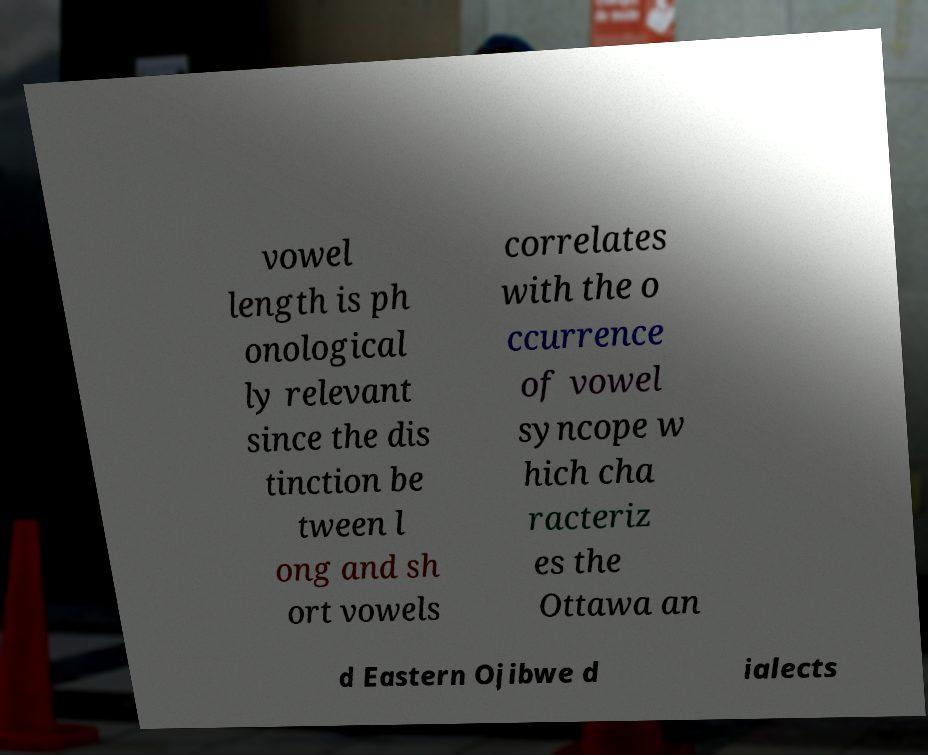For documentation purposes, I need the text within this image transcribed. Could you provide that? vowel length is ph onological ly relevant since the dis tinction be tween l ong and sh ort vowels correlates with the o ccurrence of vowel syncope w hich cha racteriz es the Ottawa an d Eastern Ojibwe d ialects 